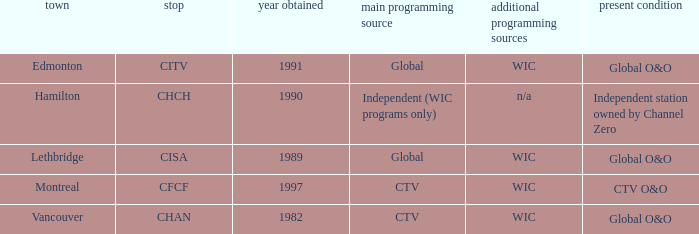How many is the minimum for citv 1991.0. 